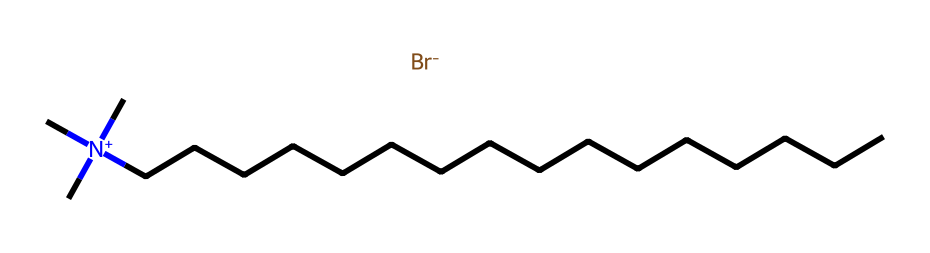What is the name of this chemical? The chemical is recognized as cetrimonium bromide, which contains a long carbon chain and a quaternary ammonium group, signified by the presence of nitrogen and the bromide ion.
Answer: cetrimonium bromide How many carbon atoms are in cetrimonium bromide? By examining the SMILES representation, it shows a chain of 16 carbon atoms (indicated by "CCCCCCCCCCCCCCCC").
Answer: 16 What type of chemical compound is cetrimonium bromide categorized as? Cetrimonium bromide contains a quaternary ammonium ion, which is characteristic of surfactants, notable for their ability to reduce surface tension.
Answer: surfactant What is the charge of the nitrogen atom in cetrimonium bromide? The nitrogen atom in cetrimonium bromide is positively charged, as indicated by the "[N+]" notation in the SMILES representation, which signifies the presence of a quaternary ammonium group.
Answer: positive How does the length of the carbon chain influence the properties of cetrimonium bromide? The long carbon chain in cetrimonium bromide contributes to its hydrophobic nature, making it effective in forming micelles and thus enhancing its surfactant properties.
Answer: increases hydrophobicity What role does the bromide ion play in cetrimonium bromide? The bromide ion acts as a counterion to the positively charged quaternary ammonium group, helping to stabilize the structure and contribute to the solubility characteristics in solution.
Answer: counterion What functional groups are present in cetrimonium bromide? The chemical shows a quaternary ammonium functional group due to the nitrogen atom's bonding to three alkyl groups and the presence of the bromide ion as the counterion.
Answer: quaternary ammonium 